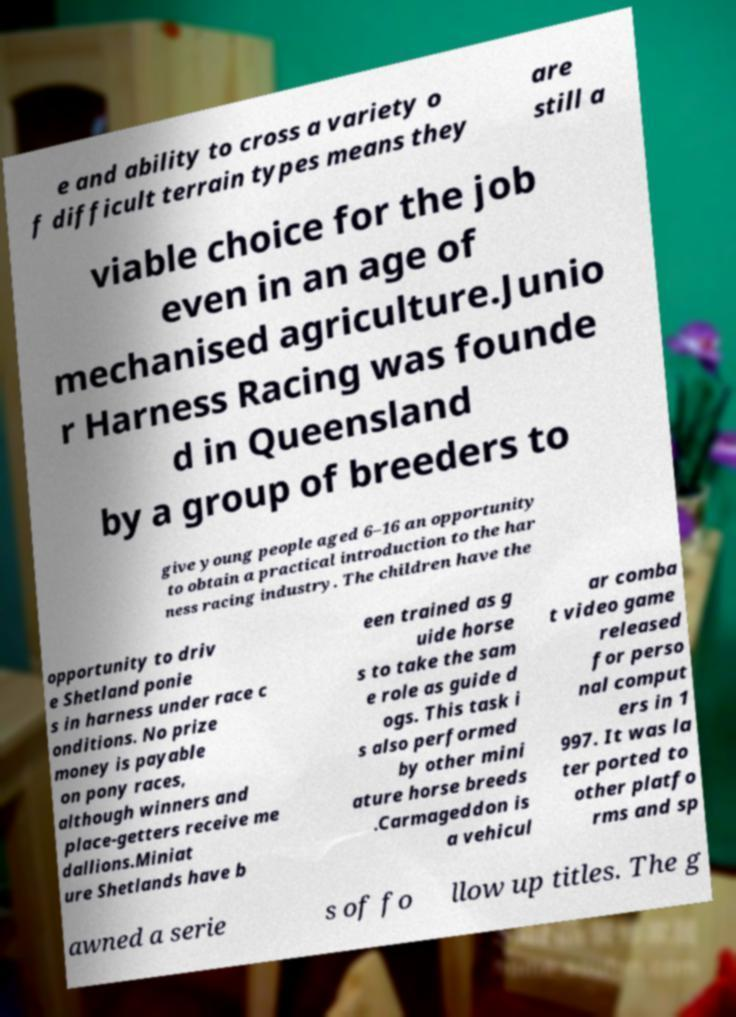Please identify and transcribe the text found in this image. e and ability to cross a variety o f difficult terrain types means they are still a viable choice for the job even in an age of mechanised agriculture.Junio r Harness Racing was founde d in Queensland by a group of breeders to give young people aged 6–16 an opportunity to obtain a practical introduction to the har ness racing industry. The children have the opportunity to driv e Shetland ponie s in harness under race c onditions. No prize money is payable on pony races, although winners and place-getters receive me dallions.Miniat ure Shetlands have b een trained as g uide horse s to take the sam e role as guide d ogs. This task i s also performed by other mini ature horse breeds .Carmageddon is a vehicul ar comba t video game released for perso nal comput ers in 1 997. It was la ter ported to other platfo rms and sp awned a serie s of fo llow up titles. The g 